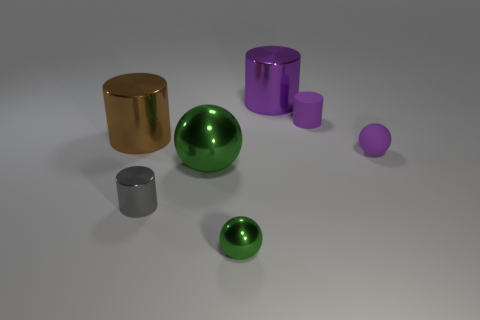Do the small rubber cylinder and the big metal cylinder right of the big green shiny sphere have the same color?
Ensure brevity in your answer.  Yes. How many other objects are there of the same color as the matte ball?
Provide a short and direct response. 2. Are there fewer large yellow matte spheres than purple spheres?
Your answer should be compact. Yes. What number of balls are right of the cylinder behind the tiny cylinder that is right of the small gray cylinder?
Offer a very short reply. 1. How big is the shiny ball behind the small gray cylinder?
Offer a terse response. Large. Do the purple object in front of the large brown metallic thing and the small green thing have the same shape?
Provide a succinct answer. Yes. What is the material of the purple thing that is the same shape as the large green metallic object?
Offer a very short reply. Rubber. Are there any small gray spheres?
Give a very brief answer. No. What material is the small cylinder that is in front of the sphere that is right of the rubber thing that is behind the purple matte sphere made of?
Offer a terse response. Metal. There is a big green metallic thing; is its shape the same as the green shiny thing right of the big sphere?
Offer a terse response. Yes. 